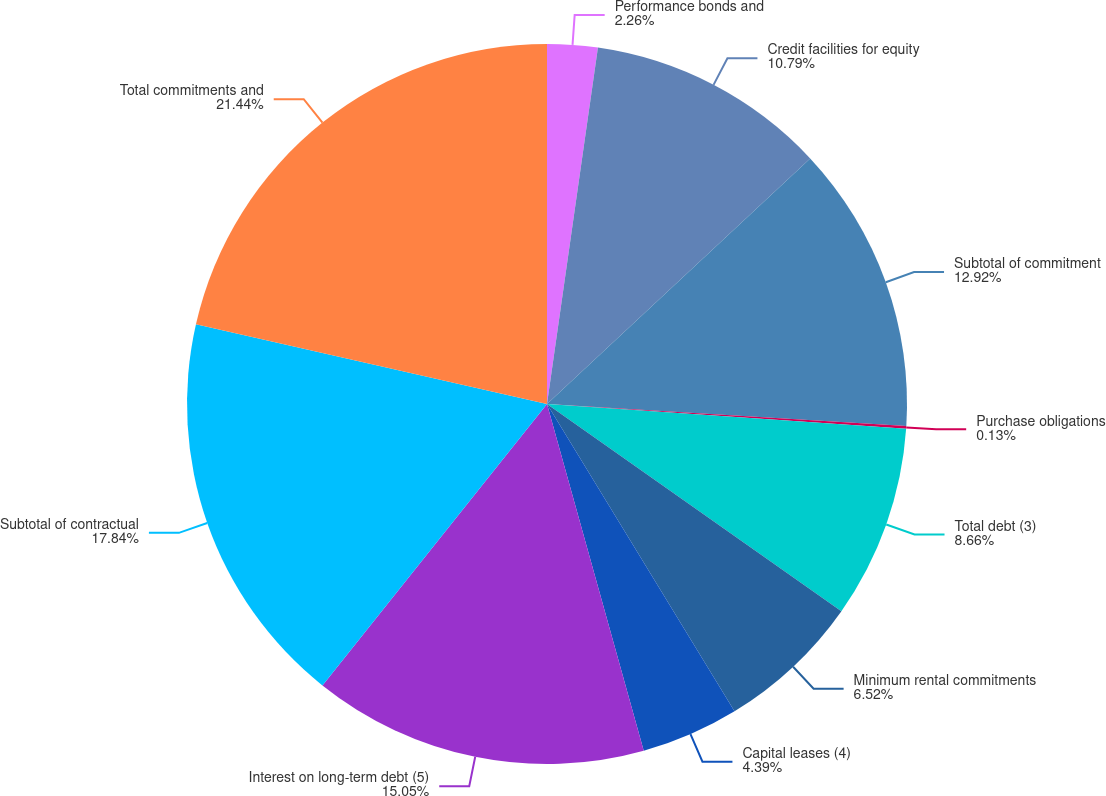<chart> <loc_0><loc_0><loc_500><loc_500><pie_chart><fcel>Performance bonds and<fcel>Credit facilities for equity<fcel>Subtotal of commitment<fcel>Purchase obligations<fcel>Total debt (3)<fcel>Minimum rental commitments<fcel>Capital leases (4)<fcel>Interest on long-term debt (5)<fcel>Subtotal of contractual<fcel>Total commitments and<nl><fcel>2.26%<fcel>10.79%<fcel>12.92%<fcel>0.13%<fcel>8.66%<fcel>6.52%<fcel>4.39%<fcel>15.05%<fcel>17.84%<fcel>21.44%<nl></chart> 